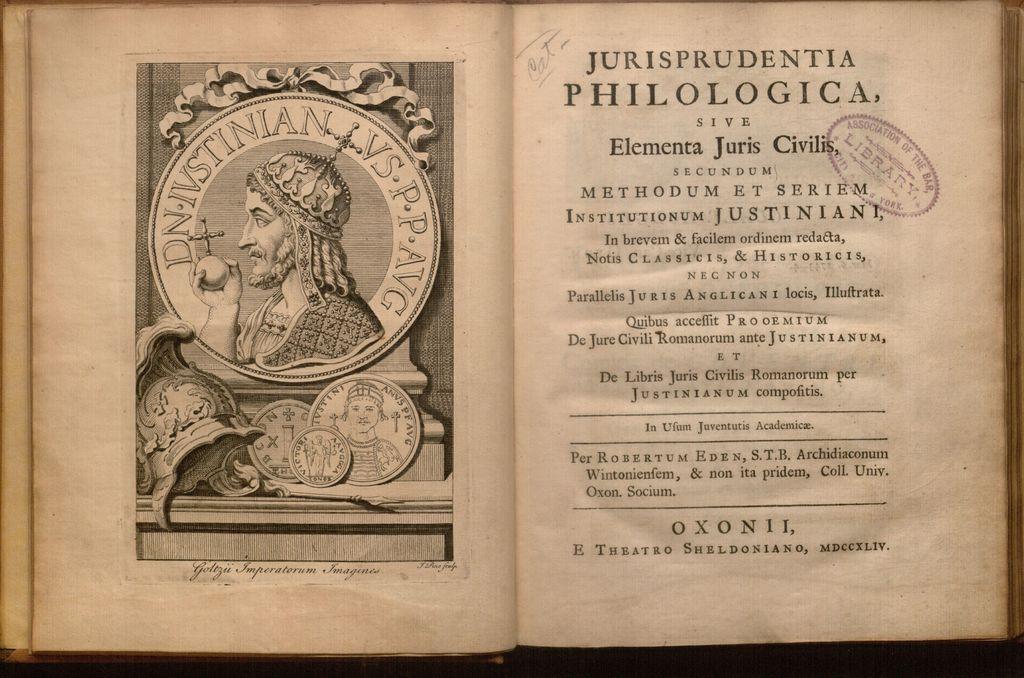What is the title of this book?
Give a very brief answer. Jurisprudentia philologica. 